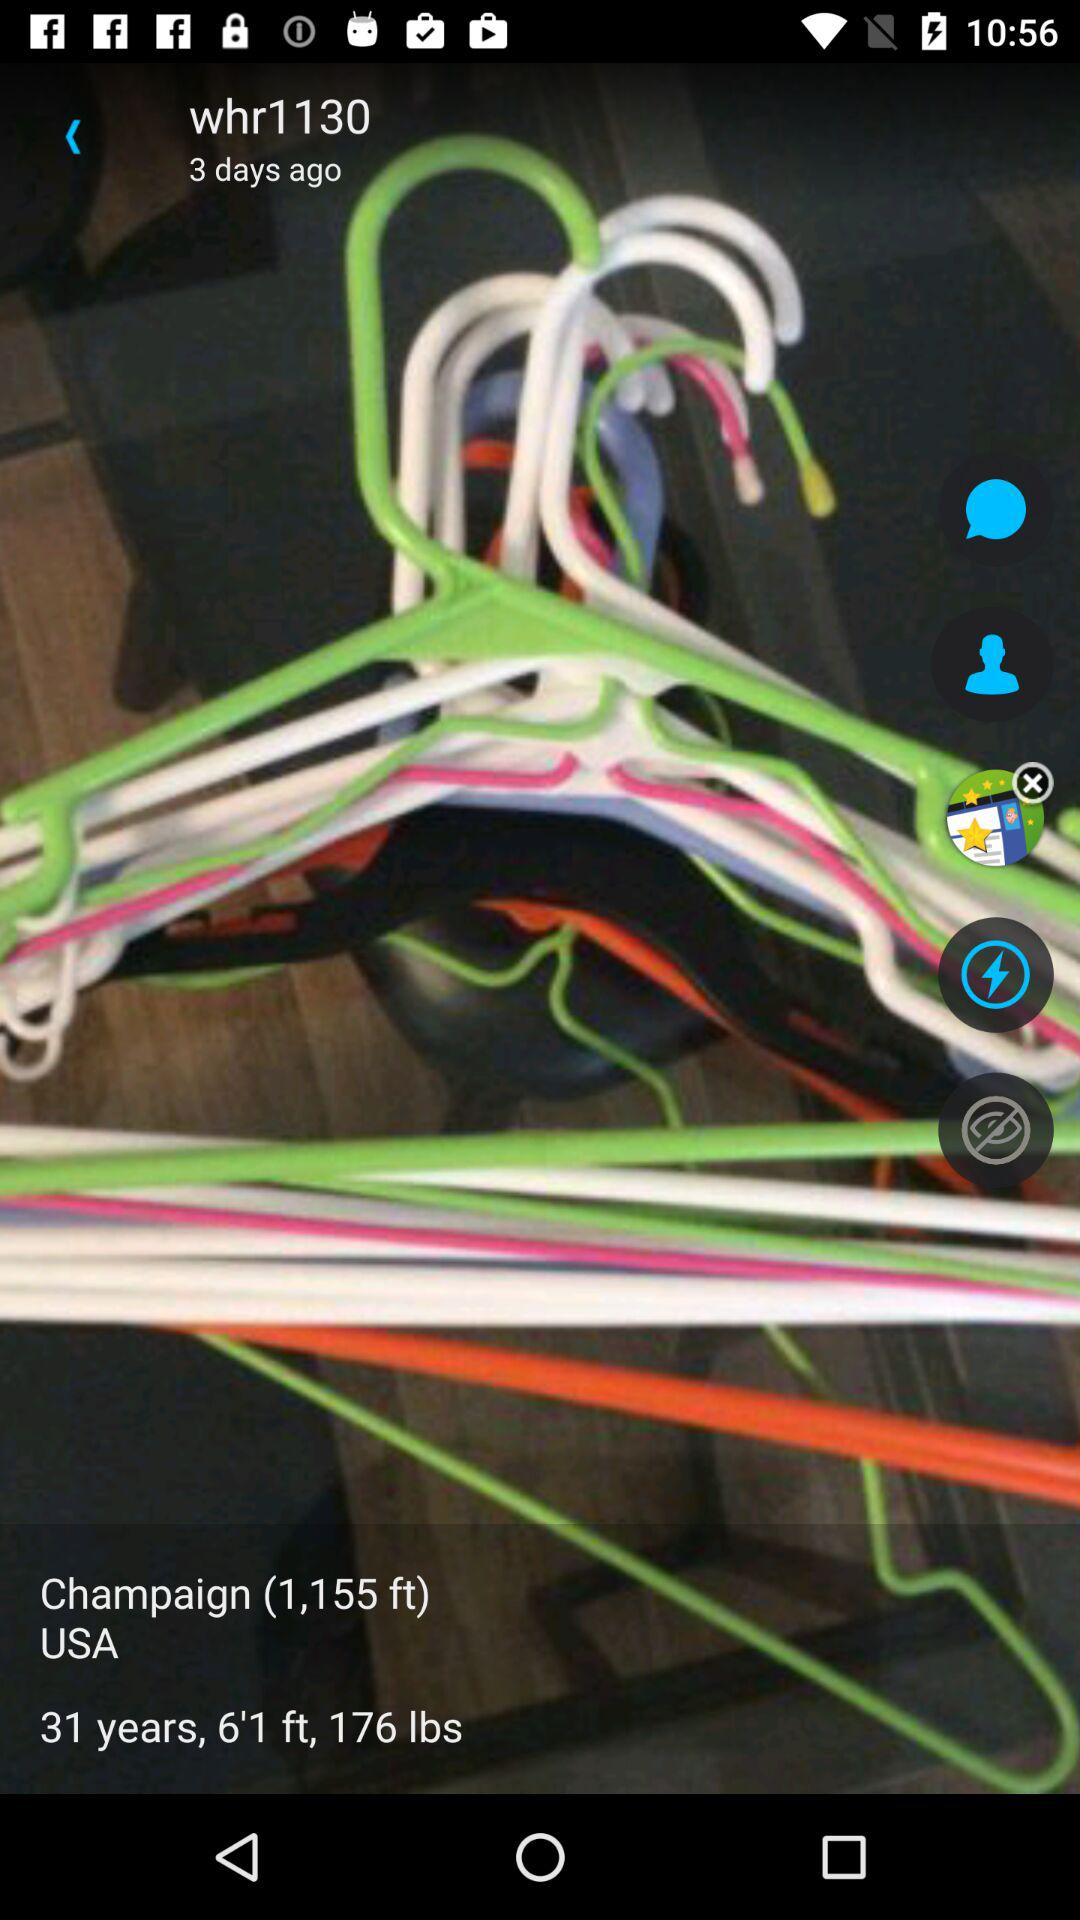What is the height of "Champaign"? The height is 1,155 feet. 